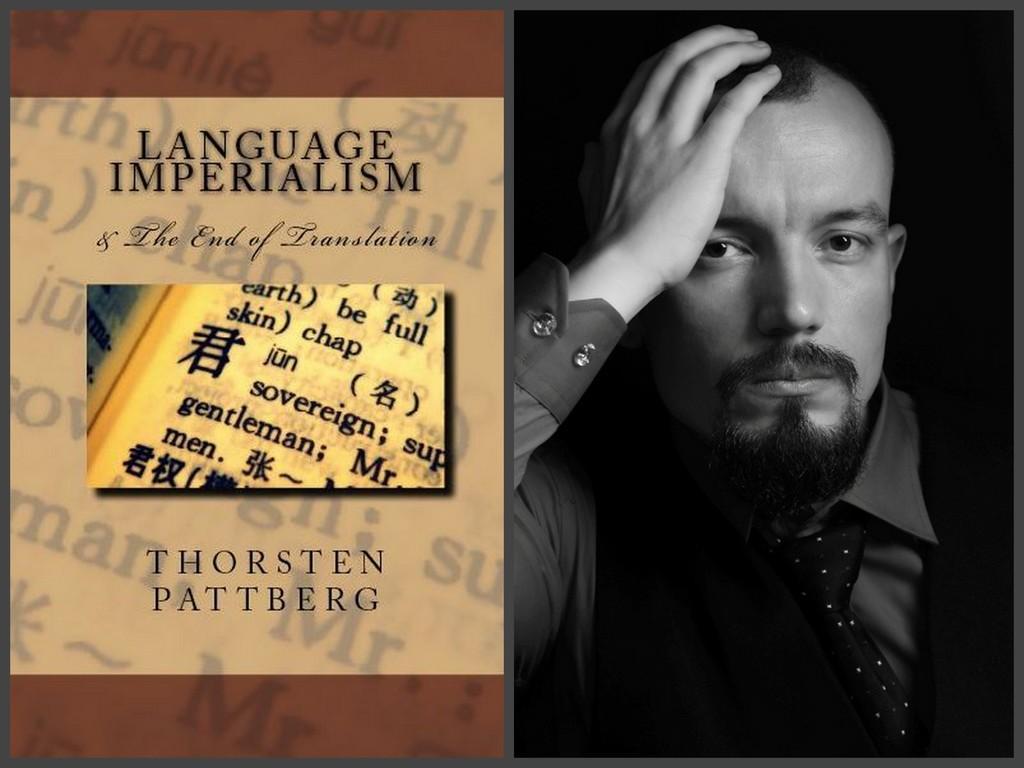How would you summarize this image in a sentence or two? In this image we can see a collage of pictures. On the right side of the image we can see a black and white photo of a person. On the left side of the image we can see a picture with some text. 